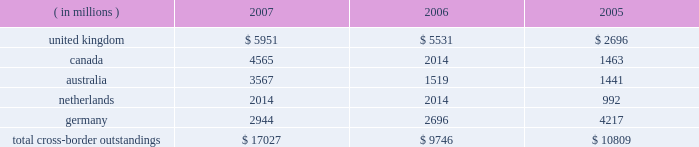Cross-border outstandings to countries in which we do business which amounted to at least 1% ( 1 % ) of our consolidated total assets were as follows as of december 31 : 2007 2006 2005 ( in millions ) .
The total cross-border outstandings presented in the table represented 12% ( 12 % ) , 9% ( 9 % ) and 11% ( 11 % ) of our consolidated total assets as of december 31 , 2007 , 2006 and 2005 , respectively .
There were no cross- border outstandings to countries which totaled between .75% ( .75 % ) and 1% ( 1 % ) of our consolidated total assets as of december 31 , 2007 .
Aggregate cross-border outstandings to countries which totaled between .75% ( .75 % ) and 1% ( 1 % ) of our consolidated total assets at december 31 , 2006 , amounted to $ 1.05 billion ( canada ) and at december 31 , 2005 , amounted to $ 1.86 billion ( belgium and japan ) .
Capital regulatory and economic capital management both use key metrics evaluated by management to ensure that our actual level of capital is commensurate with our risk profile , is in compliance with all regulatory requirements , and is sufficient to provide us with the financial flexibility to undertake future strategic business initiatives .
Regulatory capital our objective with respect to regulatory capital management is to maintain a strong capital base in order to provide financial flexibility for our business needs , including funding corporate growth and supporting customers 2019 cash management needs , and to provide protection against loss to depositors and creditors .
We strive to maintain an optimal level of capital , commensurate with our risk profile , on which an attractive return to shareholders will be realized over both the short and long term , while protecting our obligations to depositors and creditors and satisfying regulatory requirements .
Our capital management process focuses on our risk exposures , our capital position relative to our peers , regulatory capital requirements and the evaluations of the major independent credit rating agencies that assign ratings to our public debt .
The capital committee , working in conjunction with the asset and liability committee , referred to as 2018 2018alco , 2019 2019 oversees the management of regulatory capital , and is responsible for ensuring capital adequacy with respect to regulatory requirements , internal targets and the expectations of the major independent credit rating agencies .
The primary regulator of both state street and state street bank for regulatory capital purposes is the federal reserve board .
Both state street and state street bank are subject to the minimum capital requirements established by the federal reserve board and defined in the federal deposit insurance corporation improvement act of 1991 .
State street bank must meet the regulatory capital thresholds for 2018 2018well capitalized 2019 2019 in order for the parent company to maintain its status as a financial holding company. .
What are the total consolidated assets in 2006? 
Computations: (9746 / 9%)
Answer: 108288.88889. 